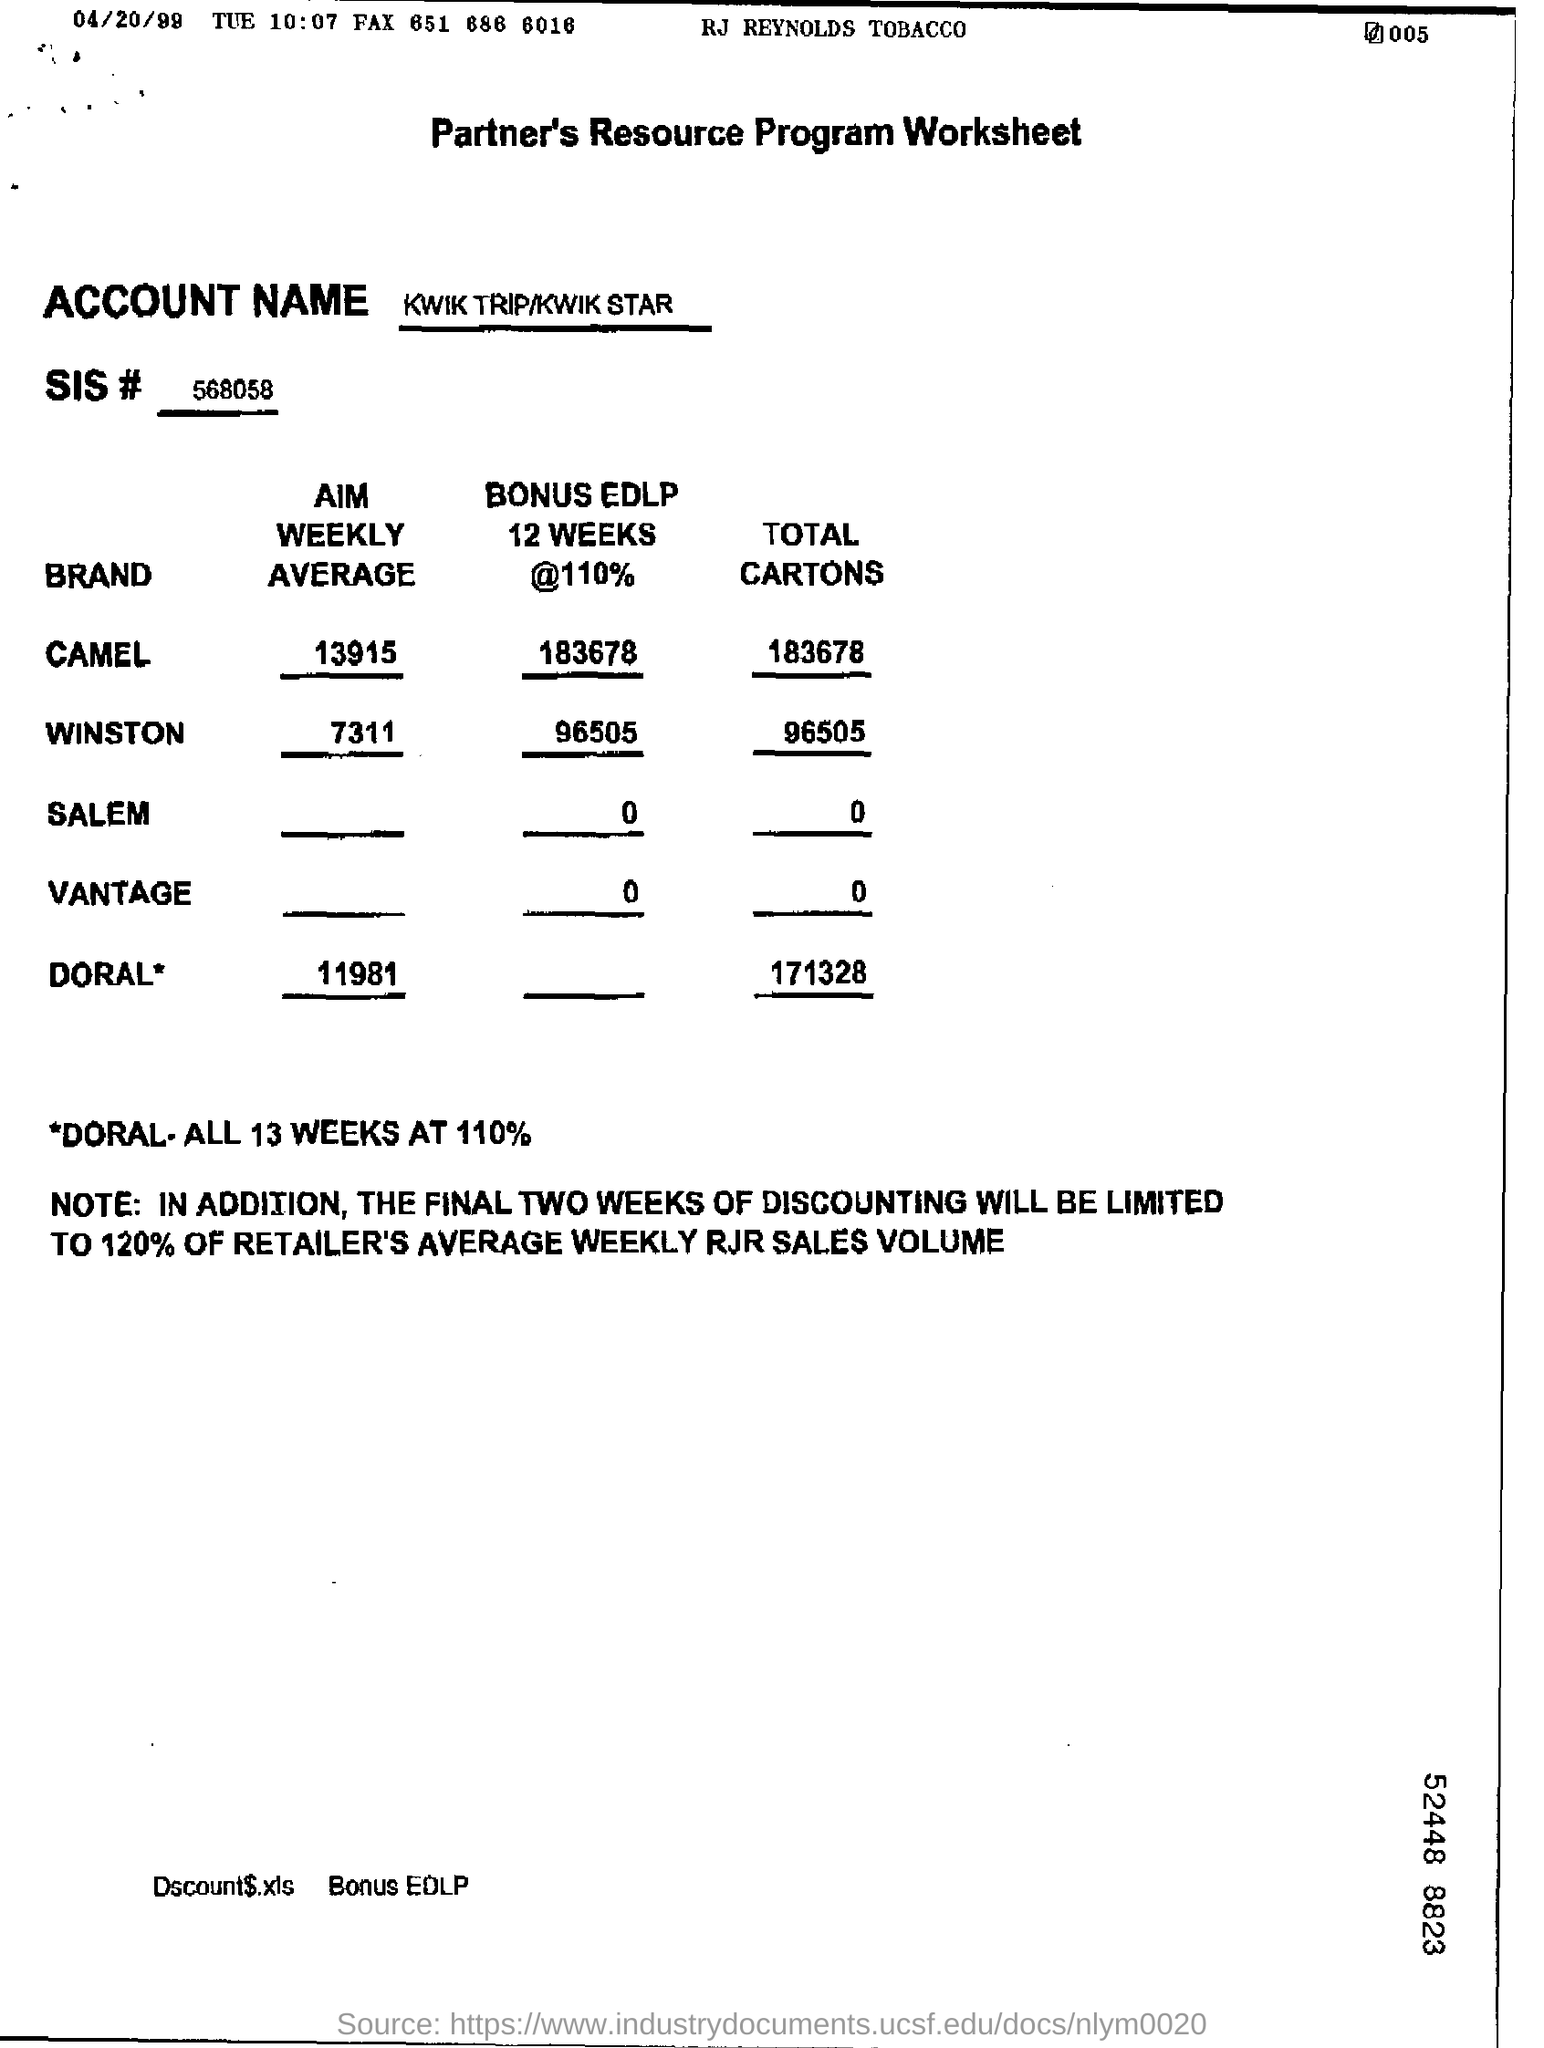What is the heading of the document?
Give a very brief answer. Partner's Resource Program Worksheet. What is the ACCOUNT NAME?
Ensure brevity in your answer.  KWIK TRIP/KWIK STAR. What is the AIM WEEKLY AVERAGE of the brand WINSTON?
Ensure brevity in your answer.  7311. What is the TOTAL CARTONS amount of VANTAGE?
Your response must be concise. 0. 